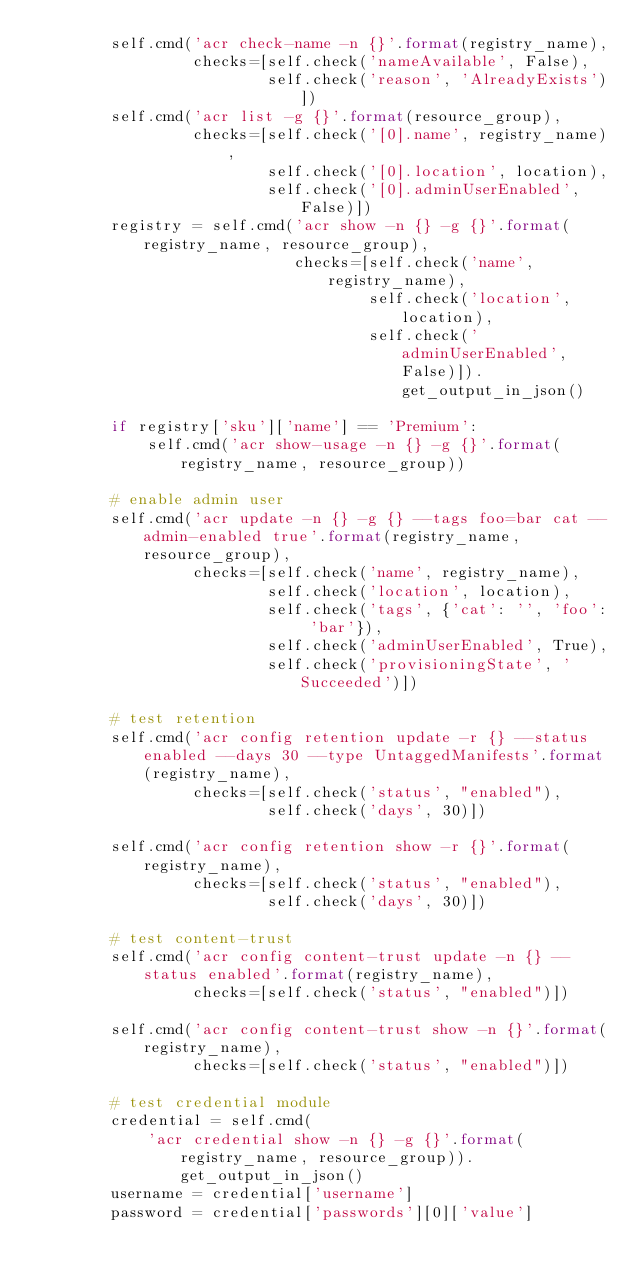Convert code to text. <code><loc_0><loc_0><loc_500><loc_500><_Python_>        self.cmd('acr check-name -n {}'.format(registry_name),
                 checks=[self.check('nameAvailable', False),
                         self.check('reason', 'AlreadyExists')])
        self.cmd('acr list -g {}'.format(resource_group),
                 checks=[self.check('[0].name', registry_name),
                         self.check('[0].location', location),
                         self.check('[0].adminUserEnabled', False)])
        registry = self.cmd('acr show -n {} -g {}'.format(registry_name, resource_group),
                            checks=[self.check('name', registry_name),
                                    self.check('location', location),
                                    self.check('adminUserEnabled', False)]).get_output_in_json()

        if registry['sku']['name'] == 'Premium':
            self.cmd('acr show-usage -n {} -g {}'.format(registry_name, resource_group))

        # enable admin user
        self.cmd('acr update -n {} -g {} --tags foo=bar cat --admin-enabled true'.format(registry_name, resource_group),
                 checks=[self.check('name', registry_name),
                         self.check('location', location),
                         self.check('tags', {'cat': '', 'foo': 'bar'}),
                         self.check('adminUserEnabled', True),
                         self.check('provisioningState', 'Succeeded')])

        # test retention
        self.cmd('acr config retention update -r {} --status enabled --days 30 --type UntaggedManifests'.format(registry_name),
                 checks=[self.check('status', "enabled"),
                         self.check('days', 30)])

        self.cmd('acr config retention show -r {}'.format(registry_name),
                 checks=[self.check('status', "enabled"),
                         self.check('days', 30)])

        # test content-trust
        self.cmd('acr config content-trust update -n {} --status enabled'.format(registry_name),
                 checks=[self.check('status', "enabled")])

        self.cmd('acr config content-trust show -n {}'.format(registry_name),
                 checks=[self.check('status', "enabled")])

        # test credential module
        credential = self.cmd(
            'acr credential show -n {} -g {}'.format(registry_name, resource_group)).get_output_in_json()
        username = credential['username']
        password = credential['passwords'][0]['value']</code> 